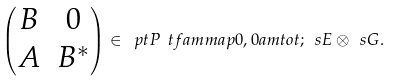<formula> <loc_0><loc_0><loc_500><loc_500>\begin{pmatrix} B & 0 \\ A & B ^ { * } \end{pmatrix} \in \ p t P { \ t f a m m a p } { 0 , 0 } { a m t o t ; \ s E \otimes \ s G } .</formula> 